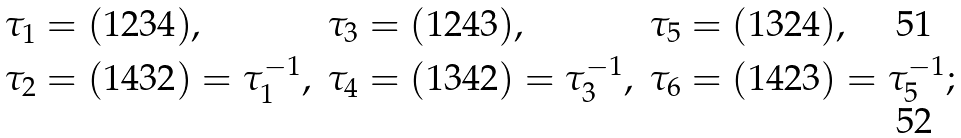Convert formula to latex. <formula><loc_0><loc_0><loc_500><loc_500>\tau _ { 1 } & = ( 1 2 3 4 ) , & \tau _ { 3 } & = ( 1 2 4 3 ) , & \tau _ { 5 } & = ( 1 3 2 4 ) , \\ \tau _ { 2 } & = ( 1 4 3 2 ) = \tau _ { 1 } ^ { - 1 } , & \tau _ { 4 } & = ( 1 3 4 2 ) = \tau _ { 3 } ^ { - 1 } , & \tau _ { 6 } & = ( 1 4 2 3 ) = \tau _ { 5 } ^ { - 1 } ;</formula> 